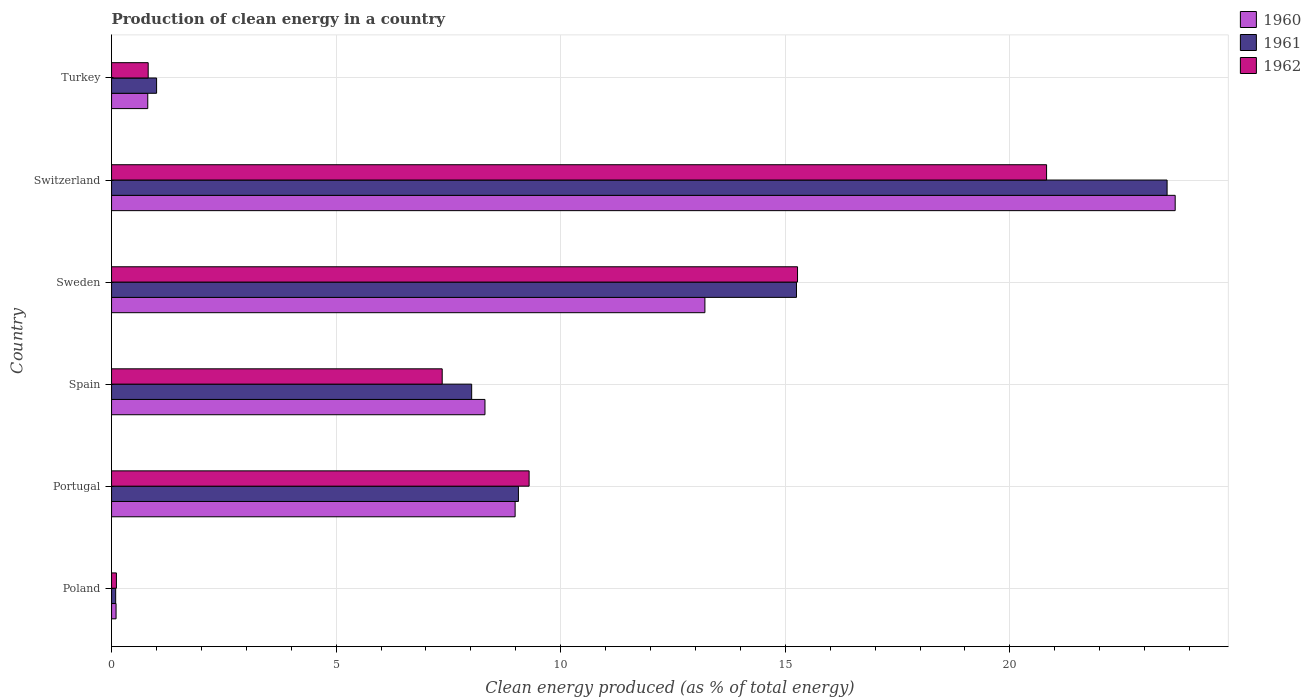How many different coloured bars are there?
Offer a very short reply. 3. Are the number of bars on each tick of the Y-axis equal?
Keep it short and to the point. Yes. How many bars are there on the 5th tick from the top?
Offer a terse response. 3. What is the label of the 6th group of bars from the top?
Provide a short and direct response. Poland. In how many cases, is the number of bars for a given country not equal to the number of legend labels?
Provide a succinct answer. 0. What is the percentage of clean energy produced in 1960 in Poland?
Give a very brief answer. 0.1. Across all countries, what is the maximum percentage of clean energy produced in 1962?
Your answer should be very brief. 20.82. Across all countries, what is the minimum percentage of clean energy produced in 1960?
Provide a succinct answer. 0.1. In which country was the percentage of clean energy produced in 1961 maximum?
Ensure brevity in your answer.  Switzerland. In which country was the percentage of clean energy produced in 1962 minimum?
Keep it short and to the point. Poland. What is the total percentage of clean energy produced in 1960 in the graph?
Your answer should be very brief. 55.1. What is the difference between the percentage of clean energy produced in 1962 in Portugal and that in Turkey?
Your response must be concise. 8.48. What is the difference between the percentage of clean energy produced in 1962 in Switzerland and the percentage of clean energy produced in 1960 in Portugal?
Offer a very short reply. 11.83. What is the average percentage of clean energy produced in 1960 per country?
Keep it short and to the point. 9.18. What is the difference between the percentage of clean energy produced in 1962 and percentage of clean energy produced in 1961 in Turkey?
Your answer should be very brief. -0.19. What is the ratio of the percentage of clean energy produced in 1961 in Sweden to that in Turkey?
Your answer should be very brief. 15.21. Is the percentage of clean energy produced in 1960 in Poland less than that in Switzerland?
Your response must be concise. Yes. What is the difference between the highest and the second highest percentage of clean energy produced in 1960?
Your answer should be compact. 10.47. What is the difference between the highest and the lowest percentage of clean energy produced in 1961?
Provide a succinct answer. 23.41. What does the 1st bar from the top in Portugal represents?
Your answer should be compact. 1962. Is it the case that in every country, the sum of the percentage of clean energy produced in 1962 and percentage of clean energy produced in 1961 is greater than the percentage of clean energy produced in 1960?
Provide a short and direct response. Yes. Are all the bars in the graph horizontal?
Your answer should be very brief. Yes. Does the graph contain any zero values?
Your answer should be compact. No. Does the graph contain grids?
Keep it short and to the point. Yes. Where does the legend appear in the graph?
Ensure brevity in your answer.  Top right. How many legend labels are there?
Offer a very short reply. 3. How are the legend labels stacked?
Keep it short and to the point. Vertical. What is the title of the graph?
Keep it short and to the point. Production of clean energy in a country. What is the label or title of the X-axis?
Offer a very short reply. Clean energy produced (as % of total energy). What is the Clean energy produced (as % of total energy) in 1960 in Poland?
Keep it short and to the point. 0.1. What is the Clean energy produced (as % of total energy) in 1961 in Poland?
Your answer should be compact. 0.09. What is the Clean energy produced (as % of total energy) of 1962 in Poland?
Keep it short and to the point. 0.11. What is the Clean energy produced (as % of total energy) of 1960 in Portugal?
Offer a very short reply. 8.99. What is the Clean energy produced (as % of total energy) of 1961 in Portugal?
Provide a short and direct response. 9.06. What is the Clean energy produced (as % of total energy) in 1962 in Portugal?
Provide a succinct answer. 9.3. What is the Clean energy produced (as % of total energy) of 1960 in Spain?
Ensure brevity in your answer.  8.31. What is the Clean energy produced (as % of total energy) of 1961 in Spain?
Make the answer very short. 8.02. What is the Clean energy produced (as % of total energy) of 1962 in Spain?
Make the answer very short. 7.36. What is the Clean energy produced (as % of total energy) of 1960 in Sweden?
Ensure brevity in your answer.  13.21. What is the Clean energy produced (as % of total energy) in 1961 in Sweden?
Offer a very short reply. 15.25. What is the Clean energy produced (as % of total energy) of 1962 in Sweden?
Offer a terse response. 15.27. What is the Clean energy produced (as % of total energy) of 1960 in Switzerland?
Your response must be concise. 23.68. What is the Clean energy produced (as % of total energy) of 1961 in Switzerland?
Offer a very short reply. 23.5. What is the Clean energy produced (as % of total energy) in 1962 in Switzerland?
Provide a succinct answer. 20.82. What is the Clean energy produced (as % of total energy) of 1960 in Turkey?
Your answer should be very brief. 0.81. What is the Clean energy produced (as % of total energy) in 1961 in Turkey?
Make the answer very short. 1. What is the Clean energy produced (as % of total energy) in 1962 in Turkey?
Offer a very short reply. 0.82. Across all countries, what is the maximum Clean energy produced (as % of total energy) of 1960?
Your response must be concise. 23.68. Across all countries, what is the maximum Clean energy produced (as % of total energy) of 1961?
Offer a terse response. 23.5. Across all countries, what is the maximum Clean energy produced (as % of total energy) in 1962?
Your response must be concise. 20.82. Across all countries, what is the minimum Clean energy produced (as % of total energy) in 1960?
Provide a short and direct response. 0.1. Across all countries, what is the minimum Clean energy produced (as % of total energy) in 1961?
Your response must be concise. 0.09. Across all countries, what is the minimum Clean energy produced (as % of total energy) in 1962?
Keep it short and to the point. 0.11. What is the total Clean energy produced (as % of total energy) in 1960 in the graph?
Make the answer very short. 55.1. What is the total Clean energy produced (as % of total energy) in 1961 in the graph?
Give a very brief answer. 56.92. What is the total Clean energy produced (as % of total energy) in 1962 in the graph?
Keep it short and to the point. 53.67. What is the difference between the Clean energy produced (as % of total energy) of 1960 in Poland and that in Portugal?
Offer a terse response. -8.88. What is the difference between the Clean energy produced (as % of total energy) in 1961 in Poland and that in Portugal?
Provide a succinct answer. -8.97. What is the difference between the Clean energy produced (as % of total energy) in 1962 in Poland and that in Portugal?
Provide a succinct answer. -9.19. What is the difference between the Clean energy produced (as % of total energy) of 1960 in Poland and that in Spain?
Offer a terse response. -8.21. What is the difference between the Clean energy produced (as % of total energy) of 1961 in Poland and that in Spain?
Provide a short and direct response. -7.93. What is the difference between the Clean energy produced (as % of total energy) of 1962 in Poland and that in Spain?
Provide a short and direct response. -7.25. What is the difference between the Clean energy produced (as % of total energy) in 1960 in Poland and that in Sweden?
Provide a succinct answer. -13.11. What is the difference between the Clean energy produced (as % of total energy) in 1961 in Poland and that in Sweden?
Your response must be concise. -15.16. What is the difference between the Clean energy produced (as % of total energy) in 1962 in Poland and that in Sweden?
Keep it short and to the point. -15.17. What is the difference between the Clean energy produced (as % of total energy) of 1960 in Poland and that in Switzerland?
Give a very brief answer. -23.58. What is the difference between the Clean energy produced (as % of total energy) of 1961 in Poland and that in Switzerland?
Your answer should be very brief. -23.41. What is the difference between the Clean energy produced (as % of total energy) in 1962 in Poland and that in Switzerland?
Provide a short and direct response. -20.71. What is the difference between the Clean energy produced (as % of total energy) in 1960 in Poland and that in Turkey?
Provide a succinct answer. -0.71. What is the difference between the Clean energy produced (as % of total energy) in 1961 in Poland and that in Turkey?
Your response must be concise. -0.91. What is the difference between the Clean energy produced (as % of total energy) of 1962 in Poland and that in Turkey?
Keep it short and to the point. -0.71. What is the difference between the Clean energy produced (as % of total energy) in 1960 in Portugal and that in Spain?
Offer a terse response. 0.67. What is the difference between the Clean energy produced (as % of total energy) in 1961 in Portugal and that in Spain?
Keep it short and to the point. 1.04. What is the difference between the Clean energy produced (as % of total energy) of 1962 in Portugal and that in Spain?
Your response must be concise. 1.94. What is the difference between the Clean energy produced (as % of total energy) of 1960 in Portugal and that in Sweden?
Provide a succinct answer. -4.23. What is the difference between the Clean energy produced (as % of total energy) in 1961 in Portugal and that in Sweden?
Your answer should be very brief. -6.19. What is the difference between the Clean energy produced (as % of total energy) of 1962 in Portugal and that in Sweden?
Provide a short and direct response. -5.98. What is the difference between the Clean energy produced (as % of total energy) of 1960 in Portugal and that in Switzerland?
Keep it short and to the point. -14.7. What is the difference between the Clean energy produced (as % of total energy) of 1961 in Portugal and that in Switzerland?
Your answer should be very brief. -14.44. What is the difference between the Clean energy produced (as % of total energy) of 1962 in Portugal and that in Switzerland?
Keep it short and to the point. -11.52. What is the difference between the Clean energy produced (as % of total energy) in 1960 in Portugal and that in Turkey?
Offer a very short reply. 8.18. What is the difference between the Clean energy produced (as % of total energy) in 1961 in Portugal and that in Turkey?
Ensure brevity in your answer.  8.06. What is the difference between the Clean energy produced (as % of total energy) in 1962 in Portugal and that in Turkey?
Keep it short and to the point. 8.48. What is the difference between the Clean energy produced (as % of total energy) of 1960 in Spain and that in Sweden?
Offer a terse response. -4.9. What is the difference between the Clean energy produced (as % of total energy) in 1961 in Spain and that in Sweden?
Offer a very short reply. -7.23. What is the difference between the Clean energy produced (as % of total energy) in 1962 in Spain and that in Sweden?
Ensure brevity in your answer.  -7.91. What is the difference between the Clean energy produced (as % of total energy) of 1960 in Spain and that in Switzerland?
Your response must be concise. -15.37. What is the difference between the Clean energy produced (as % of total energy) in 1961 in Spain and that in Switzerland?
Offer a terse response. -15.48. What is the difference between the Clean energy produced (as % of total energy) of 1962 in Spain and that in Switzerland?
Give a very brief answer. -13.46. What is the difference between the Clean energy produced (as % of total energy) of 1960 in Spain and that in Turkey?
Offer a very short reply. 7.51. What is the difference between the Clean energy produced (as % of total energy) of 1961 in Spain and that in Turkey?
Offer a very short reply. 7.02. What is the difference between the Clean energy produced (as % of total energy) of 1962 in Spain and that in Turkey?
Provide a succinct answer. 6.55. What is the difference between the Clean energy produced (as % of total energy) of 1960 in Sweden and that in Switzerland?
Provide a short and direct response. -10.47. What is the difference between the Clean energy produced (as % of total energy) in 1961 in Sweden and that in Switzerland?
Your answer should be compact. -8.25. What is the difference between the Clean energy produced (as % of total energy) of 1962 in Sweden and that in Switzerland?
Ensure brevity in your answer.  -5.55. What is the difference between the Clean energy produced (as % of total energy) of 1960 in Sweden and that in Turkey?
Ensure brevity in your answer.  12.4. What is the difference between the Clean energy produced (as % of total energy) of 1961 in Sweden and that in Turkey?
Provide a succinct answer. 14.25. What is the difference between the Clean energy produced (as % of total energy) in 1962 in Sweden and that in Turkey?
Your answer should be very brief. 14.46. What is the difference between the Clean energy produced (as % of total energy) in 1960 in Switzerland and that in Turkey?
Ensure brevity in your answer.  22.88. What is the difference between the Clean energy produced (as % of total energy) in 1961 in Switzerland and that in Turkey?
Keep it short and to the point. 22.5. What is the difference between the Clean energy produced (as % of total energy) of 1962 in Switzerland and that in Turkey?
Ensure brevity in your answer.  20. What is the difference between the Clean energy produced (as % of total energy) in 1960 in Poland and the Clean energy produced (as % of total energy) in 1961 in Portugal?
Provide a short and direct response. -8.96. What is the difference between the Clean energy produced (as % of total energy) of 1960 in Poland and the Clean energy produced (as % of total energy) of 1962 in Portugal?
Your answer should be very brief. -9.2. What is the difference between the Clean energy produced (as % of total energy) in 1961 in Poland and the Clean energy produced (as % of total energy) in 1962 in Portugal?
Offer a very short reply. -9.21. What is the difference between the Clean energy produced (as % of total energy) in 1960 in Poland and the Clean energy produced (as % of total energy) in 1961 in Spain?
Your answer should be very brief. -7.92. What is the difference between the Clean energy produced (as % of total energy) of 1960 in Poland and the Clean energy produced (as % of total energy) of 1962 in Spain?
Your answer should be very brief. -7.26. What is the difference between the Clean energy produced (as % of total energy) in 1961 in Poland and the Clean energy produced (as % of total energy) in 1962 in Spain?
Your answer should be compact. -7.27. What is the difference between the Clean energy produced (as % of total energy) of 1960 in Poland and the Clean energy produced (as % of total energy) of 1961 in Sweden?
Offer a terse response. -15.15. What is the difference between the Clean energy produced (as % of total energy) in 1960 in Poland and the Clean energy produced (as % of total energy) in 1962 in Sweden?
Your answer should be compact. -15.17. What is the difference between the Clean energy produced (as % of total energy) in 1961 in Poland and the Clean energy produced (as % of total energy) in 1962 in Sweden?
Provide a short and direct response. -15.18. What is the difference between the Clean energy produced (as % of total energy) in 1960 in Poland and the Clean energy produced (as % of total energy) in 1961 in Switzerland?
Provide a short and direct response. -23.4. What is the difference between the Clean energy produced (as % of total energy) in 1960 in Poland and the Clean energy produced (as % of total energy) in 1962 in Switzerland?
Ensure brevity in your answer.  -20.72. What is the difference between the Clean energy produced (as % of total energy) of 1961 in Poland and the Clean energy produced (as % of total energy) of 1962 in Switzerland?
Your answer should be compact. -20.73. What is the difference between the Clean energy produced (as % of total energy) of 1960 in Poland and the Clean energy produced (as % of total energy) of 1961 in Turkey?
Make the answer very short. -0.9. What is the difference between the Clean energy produced (as % of total energy) in 1960 in Poland and the Clean energy produced (as % of total energy) in 1962 in Turkey?
Keep it short and to the point. -0.72. What is the difference between the Clean energy produced (as % of total energy) in 1961 in Poland and the Clean energy produced (as % of total energy) in 1962 in Turkey?
Your answer should be very brief. -0.72. What is the difference between the Clean energy produced (as % of total energy) of 1960 in Portugal and the Clean energy produced (as % of total energy) of 1961 in Spain?
Make the answer very short. 0.97. What is the difference between the Clean energy produced (as % of total energy) in 1960 in Portugal and the Clean energy produced (as % of total energy) in 1962 in Spain?
Keep it short and to the point. 1.62. What is the difference between the Clean energy produced (as % of total energy) in 1961 in Portugal and the Clean energy produced (as % of total energy) in 1962 in Spain?
Offer a very short reply. 1.7. What is the difference between the Clean energy produced (as % of total energy) in 1960 in Portugal and the Clean energy produced (as % of total energy) in 1961 in Sweden?
Offer a terse response. -6.26. What is the difference between the Clean energy produced (as % of total energy) of 1960 in Portugal and the Clean energy produced (as % of total energy) of 1962 in Sweden?
Your response must be concise. -6.29. What is the difference between the Clean energy produced (as % of total energy) in 1961 in Portugal and the Clean energy produced (as % of total energy) in 1962 in Sweden?
Offer a terse response. -6.21. What is the difference between the Clean energy produced (as % of total energy) in 1960 in Portugal and the Clean energy produced (as % of total energy) in 1961 in Switzerland?
Provide a succinct answer. -14.52. What is the difference between the Clean energy produced (as % of total energy) of 1960 in Portugal and the Clean energy produced (as % of total energy) of 1962 in Switzerland?
Provide a short and direct response. -11.83. What is the difference between the Clean energy produced (as % of total energy) of 1961 in Portugal and the Clean energy produced (as % of total energy) of 1962 in Switzerland?
Offer a very short reply. -11.76. What is the difference between the Clean energy produced (as % of total energy) in 1960 in Portugal and the Clean energy produced (as % of total energy) in 1961 in Turkey?
Your response must be concise. 7.98. What is the difference between the Clean energy produced (as % of total energy) of 1960 in Portugal and the Clean energy produced (as % of total energy) of 1962 in Turkey?
Offer a very short reply. 8.17. What is the difference between the Clean energy produced (as % of total energy) in 1961 in Portugal and the Clean energy produced (as % of total energy) in 1962 in Turkey?
Your answer should be very brief. 8.24. What is the difference between the Clean energy produced (as % of total energy) of 1960 in Spain and the Clean energy produced (as % of total energy) of 1961 in Sweden?
Make the answer very short. -6.94. What is the difference between the Clean energy produced (as % of total energy) of 1960 in Spain and the Clean energy produced (as % of total energy) of 1962 in Sweden?
Provide a succinct answer. -6.96. What is the difference between the Clean energy produced (as % of total energy) of 1961 in Spain and the Clean energy produced (as % of total energy) of 1962 in Sweden?
Your answer should be very brief. -7.26. What is the difference between the Clean energy produced (as % of total energy) in 1960 in Spain and the Clean energy produced (as % of total energy) in 1961 in Switzerland?
Your answer should be compact. -15.19. What is the difference between the Clean energy produced (as % of total energy) of 1960 in Spain and the Clean energy produced (as % of total energy) of 1962 in Switzerland?
Your answer should be very brief. -12.5. What is the difference between the Clean energy produced (as % of total energy) in 1961 in Spain and the Clean energy produced (as % of total energy) in 1962 in Switzerland?
Your response must be concise. -12.8. What is the difference between the Clean energy produced (as % of total energy) of 1960 in Spain and the Clean energy produced (as % of total energy) of 1961 in Turkey?
Keep it short and to the point. 7.31. What is the difference between the Clean energy produced (as % of total energy) in 1960 in Spain and the Clean energy produced (as % of total energy) in 1962 in Turkey?
Provide a succinct answer. 7.5. What is the difference between the Clean energy produced (as % of total energy) of 1961 in Spain and the Clean energy produced (as % of total energy) of 1962 in Turkey?
Ensure brevity in your answer.  7.2. What is the difference between the Clean energy produced (as % of total energy) of 1960 in Sweden and the Clean energy produced (as % of total energy) of 1961 in Switzerland?
Provide a succinct answer. -10.29. What is the difference between the Clean energy produced (as % of total energy) of 1960 in Sweden and the Clean energy produced (as % of total energy) of 1962 in Switzerland?
Your answer should be very brief. -7.61. What is the difference between the Clean energy produced (as % of total energy) of 1961 in Sweden and the Clean energy produced (as % of total energy) of 1962 in Switzerland?
Make the answer very short. -5.57. What is the difference between the Clean energy produced (as % of total energy) of 1960 in Sweden and the Clean energy produced (as % of total energy) of 1961 in Turkey?
Your answer should be compact. 12.21. What is the difference between the Clean energy produced (as % of total energy) in 1960 in Sweden and the Clean energy produced (as % of total energy) in 1962 in Turkey?
Your answer should be compact. 12.4. What is the difference between the Clean energy produced (as % of total energy) of 1961 in Sweden and the Clean energy produced (as % of total energy) of 1962 in Turkey?
Your answer should be very brief. 14.43. What is the difference between the Clean energy produced (as % of total energy) in 1960 in Switzerland and the Clean energy produced (as % of total energy) in 1961 in Turkey?
Your answer should be compact. 22.68. What is the difference between the Clean energy produced (as % of total energy) in 1960 in Switzerland and the Clean energy produced (as % of total energy) in 1962 in Turkey?
Give a very brief answer. 22.87. What is the difference between the Clean energy produced (as % of total energy) in 1961 in Switzerland and the Clean energy produced (as % of total energy) in 1962 in Turkey?
Offer a very short reply. 22.69. What is the average Clean energy produced (as % of total energy) in 1960 per country?
Keep it short and to the point. 9.18. What is the average Clean energy produced (as % of total energy) in 1961 per country?
Your answer should be compact. 9.49. What is the average Clean energy produced (as % of total energy) in 1962 per country?
Your answer should be very brief. 8.95. What is the difference between the Clean energy produced (as % of total energy) of 1960 and Clean energy produced (as % of total energy) of 1961 in Poland?
Give a very brief answer. 0.01. What is the difference between the Clean energy produced (as % of total energy) in 1960 and Clean energy produced (as % of total energy) in 1962 in Poland?
Provide a short and direct response. -0.01. What is the difference between the Clean energy produced (as % of total energy) in 1961 and Clean energy produced (as % of total energy) in 1962 in Poland?
Your answer should be compact. -0.02. What is the difference between the Clean energy produced (as % of total energy) of 1960 and Clean energy produced (as % of total energy) of 1961 in Portugal?
Ensure brevity in your answer.  -0.07. What is the difference between the Clean energy produced (as % of total energy) of 1960 and Clean energy produced (as % of total energy) of 1962 in Portugal?
Provide a succinct answer. -0.31. What is the difference between the Clean energy produced (as % of total energy) in 1961 and Clean energy produced (as % of total energy) in 1962 in Portugal?
Your response must be concise. -0.24. What is the difference between the Clean energy produced (as % of total energy) in 1960 and Clean energy produced (as % of total energy) in 1961 in Spain?
Provide a short and direct response. 0.3. What is the difference between the Clean energy produced (as % of total energy) of 1960 and Clean energy produced (as % of total energy) of 1962 in Spain?
Your response must be concise. 0.95. What is the difference between the Clean energy produced (as % of total energy) in 1961 and Clean energy produced (as % of total energy) in 1962 in Spain?
Provide a succinct answer. 0.66. What is the difference between the Clean energy produced (as % of total energy) in 1960 and Clean energy produced (as % of total energy) in 1961 in Sweden?
Provide a succinct answer. -2.04. What is the difference between the Clean energy produced (as % of total energy) of 1960 and Clean energy produced (as % of total energy) of 1962 in Sweden?
Your response must be concise. -2.06. What is the difference between the Clean energy produced (as % of total energy) in 1961 and Clean energy produced (as % of total energy) in 1962 in Sweden?
Offer a very short reply. -0.02. What is the difference between the Clean energy produced (as % of total energy) of 1960 and Clean energy produced (as % of total energy) of 1961 in Switzerland?
Ensure brevity in your answer.  0.18. What is the difference between the Clean energy produced (as % of total energy) in 1960 and Clean energy produced (as % of total energy) in 1962 in Switzerland?
Offer a terse response. 2.86. What is the difference between the Clean energy produced (as % of total energy) in 1961 and Clean energy produced (as % of total energy) in 1962 in Switzerland?
Offer a very short reply. 2.68. What is the difference between the Clean energy produced (as % of total energy) of 1960 and Clean energy produced (as % of total energy) of 1961 in Turkey?
Offer a very short reply. -0.2. What is the difference between the Clean energy produced (as % of total energy) of 1960 and Clean energy produced (as % of total energy) of 1962 in Turkey?
Keep it short and to the point. -0.01. What is the difference between the Clean energy produced (as % of total energy) in 1961 and Clean energy produced (as % of total energy) in 1962 in Turkey?
Offer a terse response. 0.19. What is the ratio of the Clean energy produced (as % of total energy) of 1960 in Poland to that in Portugal?
Provide a short and direct response. 0.01. What is the ratio of the Clean energy produced (as % of total energy) in 1961 in Poland to that in Portugal?
Your answer should be very brief. 0.01. What is the ratio of the Clean energy produced (as % of total energy) of 1962 in Poland to that in Portugal?
Keep it short and to the point. 0.01. What is the ratio of the Clean energy produced (as % of total energy) in 1960 in Poland to that in Spain?
Keep it short and to the point. 0.01. What is the ratio of the Clean energy produced (as % of total energy) in 1961 in Poland to that in Spain?
Your answer should be very brief. 0.01. What is the ratio of the Clean energy produced (as % of total energy) of 1962 in Poland to that in Spain?
Keep it short and to the point. 0.01. What is the ratio of the Clean energy produced (as % of total energy) in 1960 in Poland to that in Sweden?
Your answer should be compact. 0.01. What is the ratio of the Clean energy produced (as % of total energy) in 1961 in Poland to that in Sweden?
Ensure brevity in your answer.  0.01. What is the ratio of the Clean energy produced (as % of total energy) in 1962 in Poland to that in Sweden?
Your answer should be very brief. 0.01. What is the ratio of the Clean energy produced (as % of total energy) of 1960 in Poland to that in Switzerland?
Your answer should be compact. 0. What is the ratio of the Clean energy produced (as % of total energy) in 1961 in Poland to that in Switzerland?
Keep it short and to the point. 0. What is the ratio of the Clean energy produced (as % of total energy) of 1962 in Poland to that in Switzerland?
Give a very brief answer. 0.01. What is the ratio of the Clean energy produced (as % of total energy) in 1960 in Poland to that in Turkey?
Ensure brevity in your answer.  0.12. What is the ratio of the Clean energy produced (as % of total energy) of 1961 in Poland to that in Turkey?
Keep it short and to the point. 0.09. What is the ratio of the Clean energy produced (as % of total energy) in 1962 in Poland to that in Turkey?
Provide a short and direct response. 0.13. What is the ratio of the Clean energy produced (as % of total energy) of 1960 in Portugal to that in Spain?
Ensure brevity in your answer.  1.08. What is the ratio of the Clean energy produced (as % of total energy) in 1961 in Portugal to that in Spain?
Provide a short and direct response. 1.13. What is the ratio of the Clean energy produced (as % of total energy) in 1962 in Portugal to that in Spain?
Keep it short and to the point. 1.26. What is the ratio of the Clean energy produced (as % of total energy) in 1960 in Portugal to that in Sweden?
Your response must be concise. 0.68. What is the ratio of the Clean energy produced (as % of total energy) of 1961 in Portugal to that in Sweden?
Provide a short and direct response. 0.59. What is the ratio of the Clean energy produced (as % of total energy) of 1962 in Portugal to that in Sweden?
Your response must be concise. 0.61. What is the ratio of the Clean energy produced (as % of total energy) in 1960 in Portugal to that in Switzerland?
Offer a terse response. 0.38. What is the ratio of the Clean energy produced (as % of total energy) of 1961 in Portugal to that in Switzerland?
Your answer should be very brief. 0.39. What is the ratio of the Clean energy produced (as % of total energy) in 1962 in Portugal to that in Switzerland?
Keep it short and to the point. 0.45. What is the ratio of the Clean energy produced (as % of total energy) of 1960 in Portugal to that in Turkey?
Make the answer very short. 11.15. What is the ratio of the Clean energy produced (as % of total energy) of 1961 in Portugal to that in Turkey?
Keep it short and to the point. 9.03. What is the ratio of the Clean energy produced (as % of total energy) of 1962 in Portugal to that in Turkey?
Your answer should be very brief. 11.4. What is the ratio of the Clean energy produced (as % of total energy) of 1960 in Spain to that in Sweden?
Make the answer very short. 0.63. What is the ratio of the Clean energy produced (as % of total energy) in 1961 in Spain to that in Sweden?
Your answer should be compact. 0.53. What is the ratio of the Clean energy produced (as % of total energy) in 1962 in Spain to that in Sweden?
Make the answer very short. 0.48. What is the ratio of the Clean energy produced (as % of total energy) in 1960 in Spain to that in Switzerland?
Your answer should be very brief. 0.35. What is the ratio of the Clean energy produced (as % of total energy) in 1961 in Spain to that in Switzerland?
Your response must be concise. 0.34. What is the ratio of the Clean energy produced (as % of total energy) in 1962 in Spain to that in Switzerland?
Make the answer very short. 0.35. What is the ratio of the Clean energy produced (as % of total energy) in 1960 in Spain to that in Turkey?
Your answer should be compact. 10.31. What is the ratio of the Clean energy produced (as % of total energy) of 1961 in Spain to that in Turkey?
Your response must be concise. 8. What is the ratio of the Clean energy produced (as % of total energy) of 1962 in Spain to that in Turkey?
Ensure brevity in your answer.  9.03. What is the ratio of the Clean energy produced (as % of total energy) in 1960 in Sweden to that in Switzerland?
Your response must be concise. 0.56. What is the ratio of the Clean energy produced (as % of total energy) of 1961 in Sweden to that in Switzerland?
Provide a short and direct response. 0.65. What is the ratio of the Clean energy produced (as % of total energy) in 1962 in Sweden to that in Switzerland?
Offer a terse response. 0.73. What is the ratio of the Clean energy produced (as % of total energy) in 1960 in Sweden to that in Turkey?
Provide a short and direct response. 16.39. What is the ratio of the Clean energy produced (as % of total energy) in 1961 in Sweden to that in Turkey?
Your response must be concise. 15.21. What is the ratio of the Clean energy produced (as % of total energy) of 1962 in Sweden to that in Turkey?
Give a very brief answer. 18.73. What is the ratio of the Clean energy produced (as % of total energy) in 1960 in Switzerland to that in Turkey?
Your answer should be compact. 29.38. What is the ratio of the Clean energy produced (as % of total energy) in 1961 in Switzerland to that in Turkey?
Your answer should be very brief. 23.44. What is the ratio of the Clean energy produced (as % of total energy) in 1962 in Switzerland to that in Turkey?
Ensure brevity in your answer.  25.53. What is the difference between the highest and the second highest Clean energy produced (as % of total energy) in 1960?
Make the answer very short. 10.47. What is the difference between the highest and the second highest Clean energy produced (as % of total energy) in 1961?
Your answer should be compact. 8.25. What is the difference between the highest and the second highest Clean energy produced (as % of total energy) of 1962?
Your response must be concise. 5.55. What is the difference between the highest and the lowest Clean energy produced (as % of total energy) in 1960?
Keep it short and to the point. 23.58. What is the difference between the highest and the lowest Clean energy produced (as % of total energy) in 1961?
Your answer should be compact. 23.41. What is the difference between the highest and the lowest Clean energy produced (as % of total energy) of 1962?
Offer a very short reply. 20.71. 